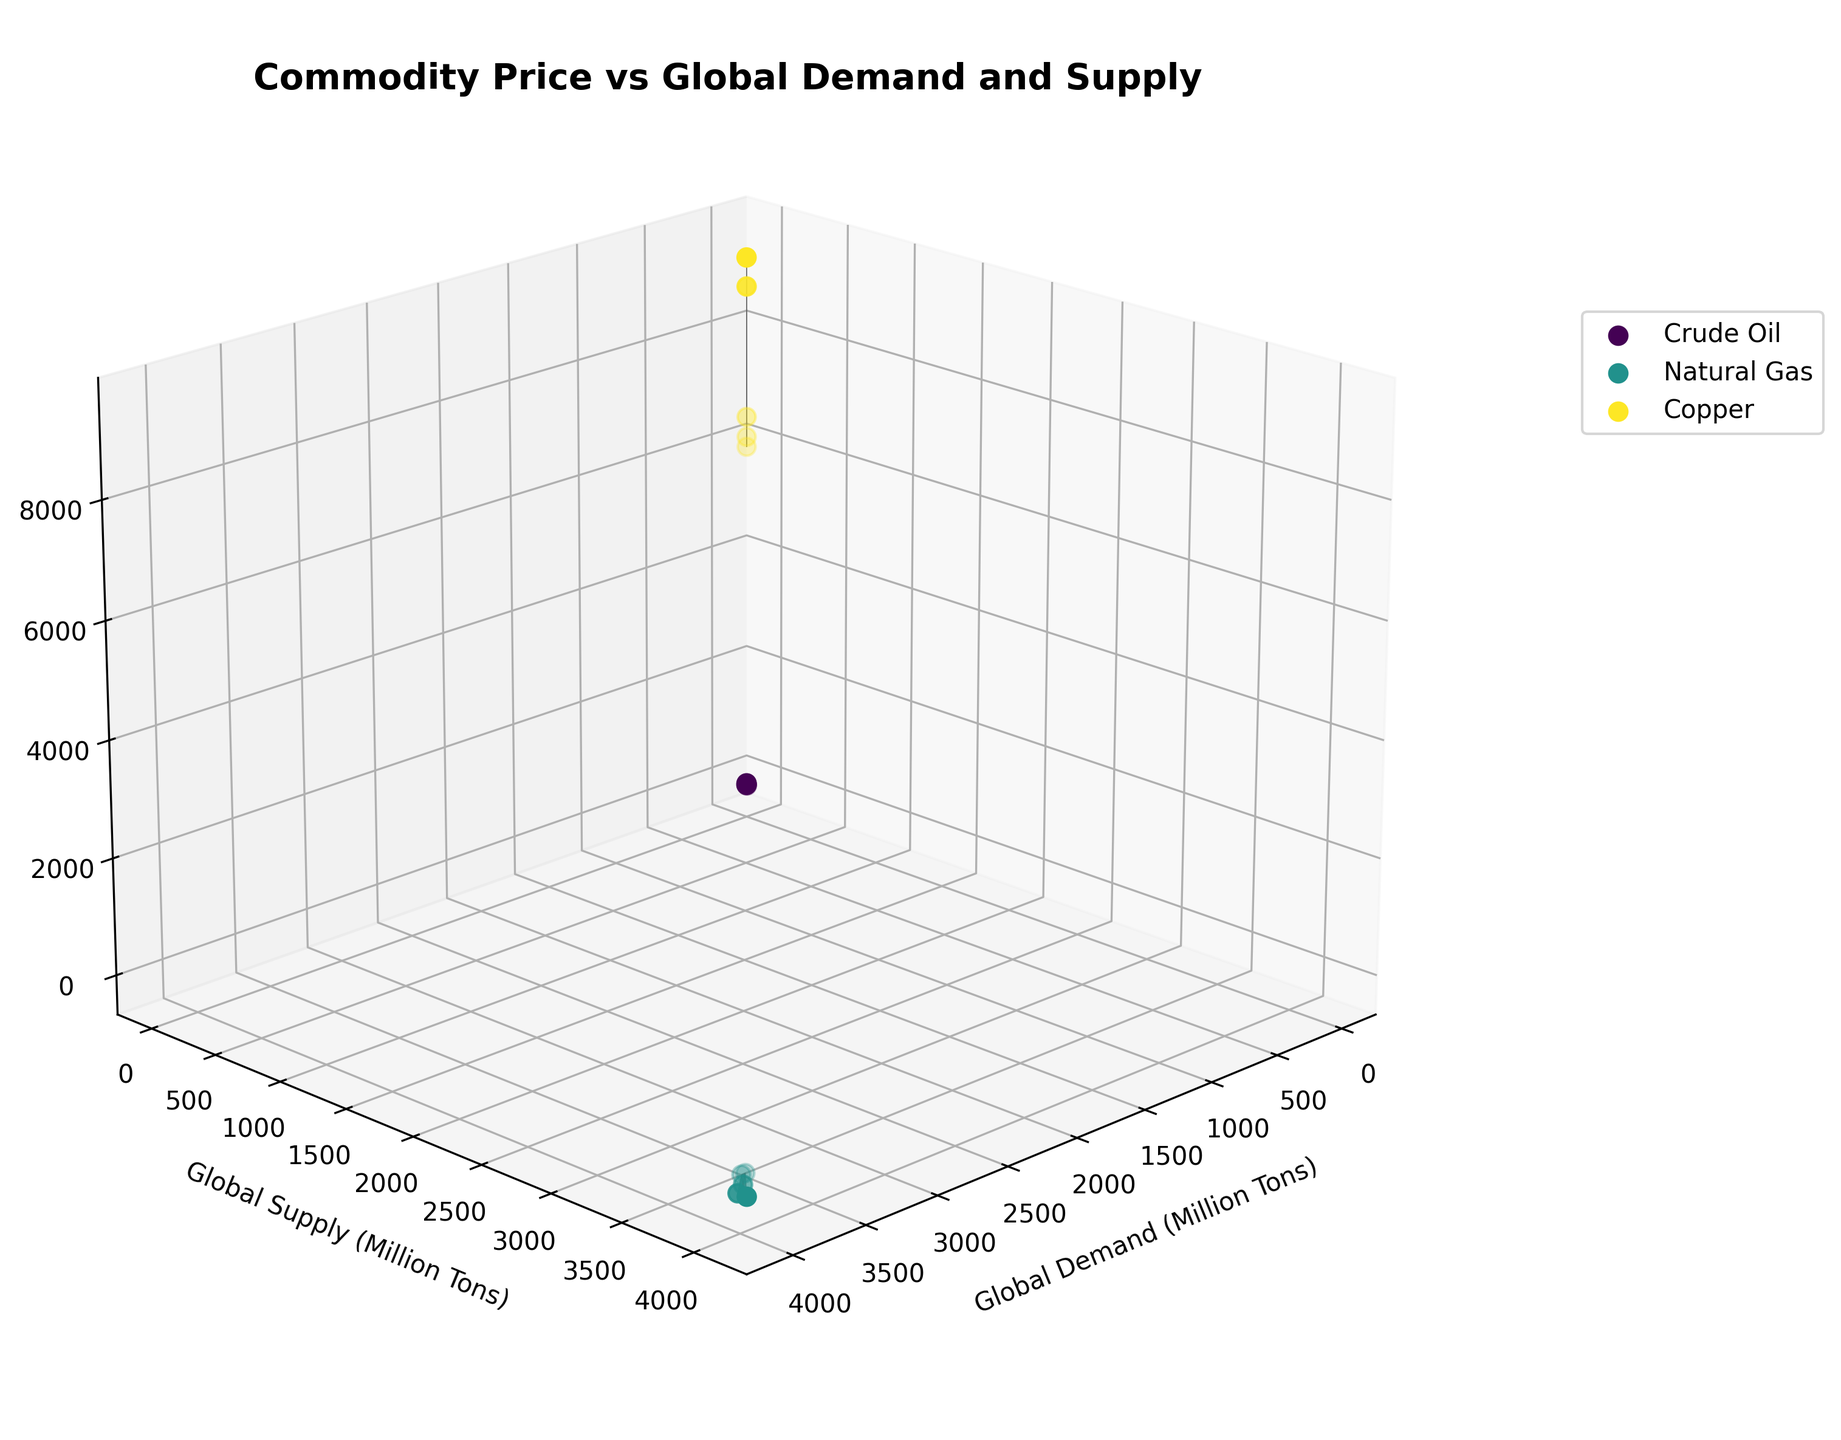What is the title of the plot? The title of the plot is displayed prominently at the top of the figure and can be easily identified.
Answer: Commodity Price vs Global Demand and Supply How many distinct commodities are included in the plot? By looking at the legend on the right side of the plot, we can count the different commodities listed.
Answer: 3 Which commodity generally shows the highest price fluctuation? By observing the scatter points and surface plot for each commodity, we can see which has the widest range in the Z-axis (Price).
Answer: Copper What are the axes labels in the plot? The labels can be found along each axis. The x-axis label is along the horizontal front edge, the y-axis label along the horizontal side edge, and the z-axis label along the vertical edge.
Answer: Global Demand (Million Tons), Global Supply (Million Tons), Price (USD/Ton) Which year has the highest price for crude oil? By identifying the peak point on the Crude Oil surface plot and cross-referencing the colors and legend, we can find the corresponding year.
Answer: 2022 Compare the global demand and supply of Natural Gas in 2022. Which was higher? By locating the 2022 data point for Natural Gas, we can compare its demand and supply values visually on the plot.
Answer: Global Supply What is the price trend of Crude Oil from 2018 to 2022 as global demand increases? By examining the Crude Oil surface plot from left to right (representing increasing years and demand), we can observe the trend on the Z-axis (Price).
Answer: Increasing Among the commodities, which one shows a price decrease when both global demand and supply are near maximum values? By analyzing the surface plots for all commodities around their maximum demand and supply values, we see which declines in price.
Answer: Natural Gas What's the difference in the price of Copper between 2018 and 2021? Locate the scatter points for Copper in 2018 and 2021, refer to the Z-axis (Price) for each, and calculate the difference.
Answer: 2787.7 USD Compare the price fluctuation pattern of Natural Gas and Crude Oil during 2020. Which has a steeper price change? By observing the surface plots around the year 2020 for both commodities, check which one has a steeper slope in the Z-axis (Price).
Answer: Crude Oil 